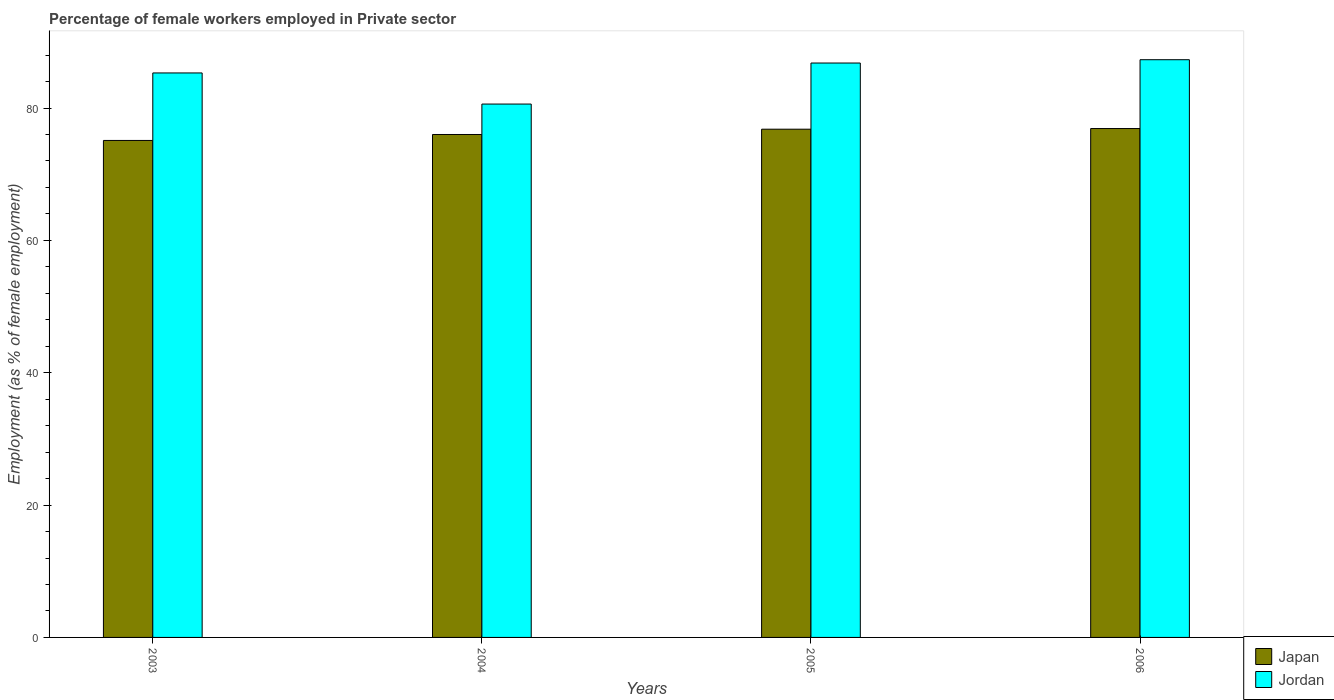How many groups of bars are there?
Provide a succinct answer. 4. How many bars are there on the 3rd tick from the right?
Give a very brief answer. 2. What is the label of the 1st group of bars from the left?
Provide a short and direct response. 2003. In how many cases, is the number of bars for a given year not equal to the number of legend labels?
Ensure brevity in your answer.  0. What is the percentage of females employed in Private sector in Japan in 2005?
Your answer should be very brief. 76.8. Across all years, what is the maximum percentage of females employed in Private sector in Japan?
Offer a very short reply. 76.9. Across all years, what is the minimum percentage of females employed in Private sector in Japan?
Offer a very short reply. 75.1. In which year was the percentage of females employed in Private sector in Japan minimum?
Offer a terse response. 2003. What is the total percentage of females employed in Private sector in Jordan in the graph?
Ensure brevity in your answer.  340. What is the difference between the percentage of females employed in Private sector in Japan in 2004 and that in 2005?
Offer a very short reply. -0.8. What is the average percentage of females employed in Private sector in Japan per year?
Offer a terse response. 76.2. In the year 2005, what is the difference between the percentage of females employed in Private sector in Japan and percentage of females employed in Private sector in Jordan?
Ensure brevity in your answer.  -10. What is the ratio of the percentage of females employed in Private sector in Jordan in 2004 to that in 2006?
Provide a succinct answer. 0.92. What is the difference between the highest and the second highest percentage of females employed in Private sector in Jordan?
Provide a short and direct response. 0.5. What is the difference between the highest and the lowest percentage of females employed in Private sector in Japan?
Make the answer very short. 1.8. Is the sum of the percentage of females employed in Private sector in Japan in 2003 and 2006 greater than the maximum percentage of females employed in Private sector in Jordan across all years?
Ensure brevity in your answer.  Yes. What does the 2nd bar from the left in 2006 represents?
Provide a short and direct response. Jordan. What does the 1st bar from the right in 2006 represents?
Offer a terse response. Jordan. Are all the bars in the graph horizontal?
Your answer should be compact. No. How many years are there in the graph?
Give a very brief answer. 4. What is the title of the graph?
Provide a succinct answer. Percentage of female workers employed in Private sector. Does "Greenland" appear as one of the legend labels in the graph?
Offer a very short reply. No. What is the label or title of the Y-axis?
Your response must be concise. Employment (as % of female employment). What is the Employment (as % of female employment) in Japan in 2003?
Offer a terse response. 75.1. What is the Employment (as % of female employment) of Jordan in 2003?
Provide a succinct answer. 85.3. What is the Employment (as % of female employment) in Japan in 2004?
Provide a succinct answer. 76. What is the Employment (as % of female employment) of Jordan in 2004?
Offer a very short reply. 80.6. What is the Employment (as % of female employment) of Japan in 2005?
Offer a terse response. 76.8. What is the Employment (as % of female employment) of Jordan in 2005?
Provide a short and direct response. 86.8. What is the Employment (as % of female employment) of Japan in 2006?
Make the answer very short. 76.9. What is the Employment (as % of female employment) of Jordan in 2006?
Keep it short and to the point. 87.3. Across all years, what is the maximum Employment (as % of female employment) of Japan?
Keep it short and to the point. 76.9. Across all years, what is the maximum Employment (as % of female employment) of Jordan?
Your answer should be compact. 87.3. Across all years, what is the minimum Employment (as % of female employment) in Japan?
Offer a very short reply. 75.1. Across all years, what is the minimum Employment (as % of female employment) in Jordan?
Your answer should be very brief. 80.6. What is the total Employment (as % of female employment) of Japan in the graph?
Keep it short and to the point. 304.8. What is the total Employment (as % of female employment) of Jordan in the graph?
Make the answer very short. 340. What is the difference between the Employment (as % of female employment) of Japan in 2003 and that in 2005?
Keep it short and to the point. -1.7. What is the difference between the Employment (as % of female employment) in Jordan in 2003 and that in 2006?
Keep it short and to the point. -2. What is the difference between the Employment (as % of female employment) in Japan in 2004 and that in 2005?
Provide a short and direct response. -0.8. What is the difference between the Employment (as % of female employment) in Jordan in 2004 and that in 2005?
Give a very brief answer. -6.2. What is the difference between the Employment (as % of female employment) of Jordan in 2004 and that in 2006?
Provide a succinct answer. -6.7. What is the difference between the Employment (as % of female employment) in Japan in 2003 and the Employment (as % of female employment) in Jordan in 2005?
Keep it short and to the point. -11.7. What is the difference between the Employment (as % of female employment) of Japan in 2004 and the Employment (as % of female employment) of Jordan in 2006?
Keep it short and to the point. -11.3. What is the difference between the Employment (as % of female employment) in Japan in 2005 and the Employment (as % of female employment) in Jordan in 2006?
Provide a succinct answer. -10.5. What is the average Employment (as % of female employment) in Japan per year?
Offer a very short reply. 76.2. What is the average Employment (as % of female employment) of Jordan per year?
Offer a very short reply. 85. In the year 2003, what is the difference between the Employment (as % of female employment) of Japan and Employment (as % of female employment) of Jordan?
Offer a very short reply. -10.2. What is the ratio of the Employment (as % of female employment) of Japan in 2003 to that in 2004?
Provide a succinct answer. 0.99. What is the ratio of the Employment (as % of female employment) of Jordan in 2003 to that in 2004?
Give a very brief answer. 1.06. What is the ratio of the Employment (as % of female employment) in Japan in 2003 to that in 2005?
Your response must be concise. 0.98. What is the ratio of the Employment (as % of female employment) in Jordan in 2003 to that in 2005?
Provide a short and direct response. 0.98. What is the ratio of the Employment (as % of female employment) of Japan in 2003 to that in 2006?
Give a very brief answer. 0.98. What is the ratio of the Employment (as % of female employment) of Jordan in 2003 to that in 2006?
Your response must be concise. 0.98. What is the ratio of the Employment (as % of female employment) in Jordan in 2004 to that in 2005?
Offer a very short reply. 0.93. What is the ratio of the Employment (as % of female employment) in Japan in 2004 to that in 2006?
Offer a terse response. 0.99. What is the ratio of the Employment (as % of female employment) of Jordan in 2004 to that in 2006?
Ensure brevity in your answer.  0.92. What is the difference between the highest and the second highest Employment (as % of female employment) in Japan?
Give a very brief answer. 0.1. What is the difference between the highest and the second highest Employment (as % of female employment) in Jordan?
Your answer should be very brief. 0.5. What is the difference between the highest and the lowest Employment (as % of female employment) in Japan?
Your answer should be compact. 1.8. 